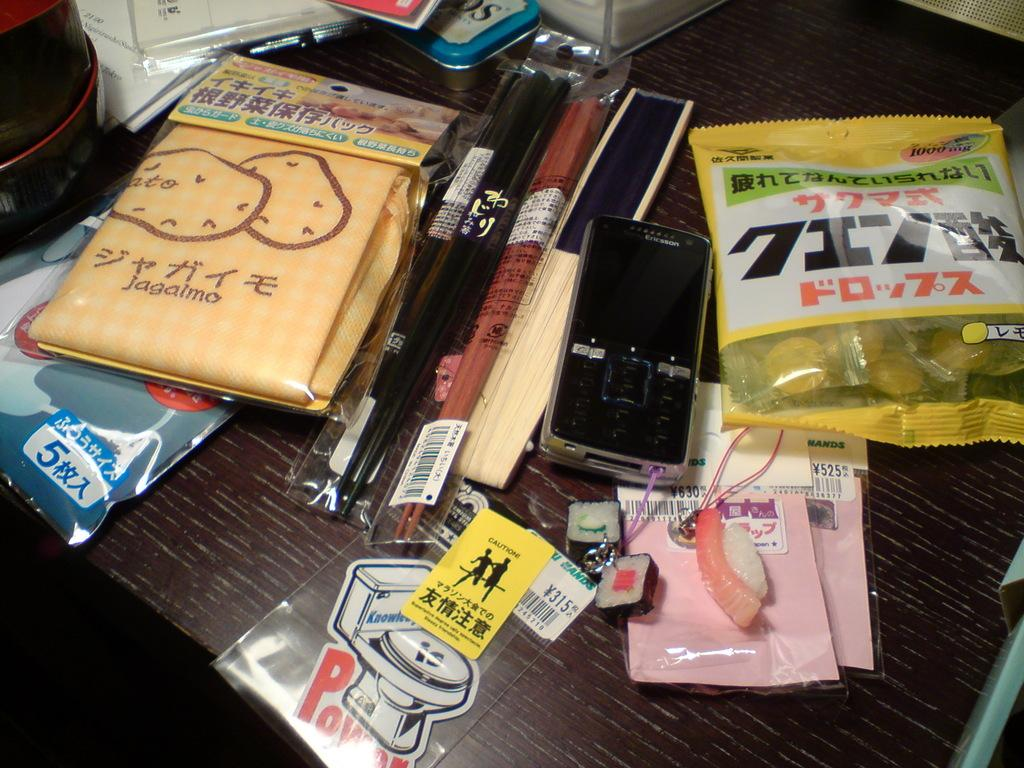<image>
Write a terse but informative summary of the picture. A shelf has packages on it including one that has a picture of a toilet with the word POW beneath it and a Caution sticker on the packaging. 